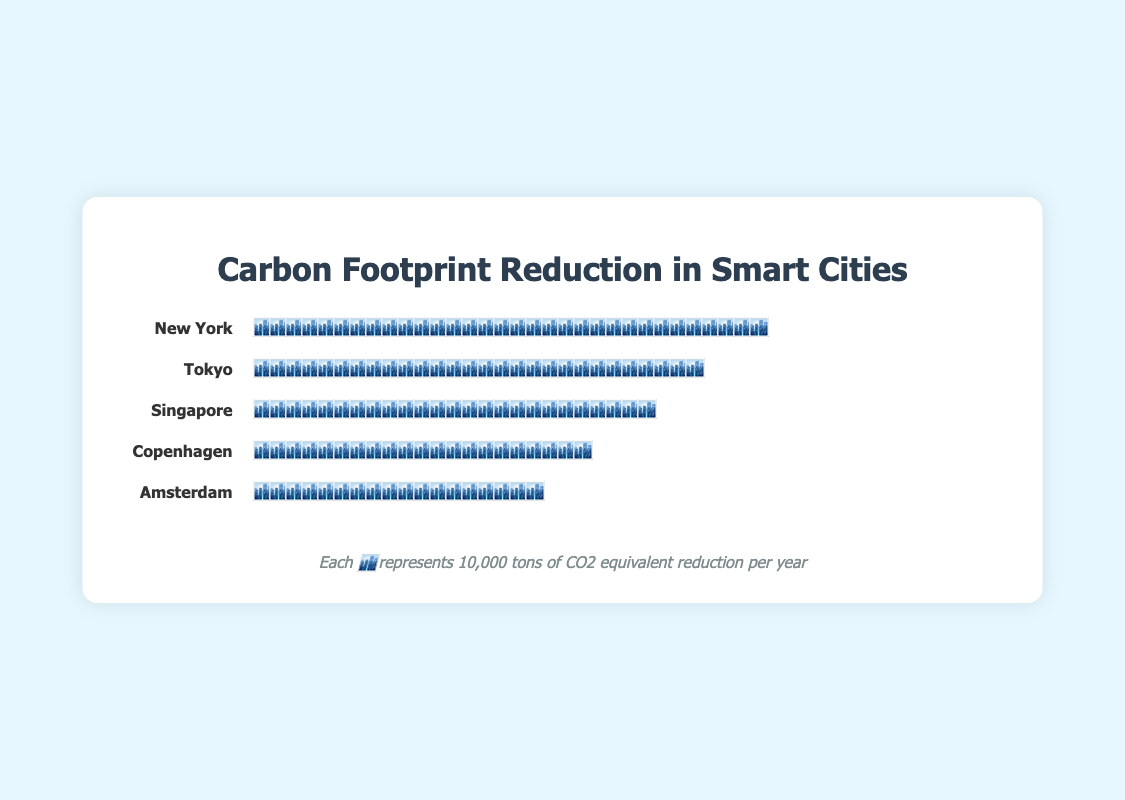What is the total carbon footprint reduction for New York? The figure shows that each 🏙️ icon represents 10,000 tons of CO2 reduction per year. By counting the icons for New York, we see there are 32 icons, so the total reduction is 32 * 10,000.
Answer: 320,000 tons of CO2 Which city has the second highest carbon footprint reduction? The figure indicates that Tokyo has 28 icons representing 280,000 tons of CO2 reduction per year, which is the second highest after New York.
Answer: Tokyo How much more carbon footprint reduction does New York achieve compared to Amsterdam? New York has 32 icons representing 320,000 tons, while Amsterdam has 18 icons representing 180,000 tons. The difference is calculated as 320,000 - 180,000.
Answer: 140,000 tons of CO2 Which city has the lowest carbon footprint reduction? Counting the icons, Amsterdam has the fewest with 18 icons, which represent 180,000 tons of CO2 reduction per year.
Answer: Amsterdam What is the combined carbon footprint reduction of Singapore and Copenhagen? Singapore has 25 icons (250,000 tons) and Copenhagen has 21 icons (210,000 tons). Adding these gives 250,000 + 210,000.
Answer: 460,000 tons of CO2 Which two cities have a combined reduction greater than New York's reduction? New York's reduction is 320,000 tons. Tokyo and Singapore together make 280,000 + 250,000 which sums to 530,000 tons, greater than New York's.
Answer: Tokyo and Singapore How many total icons represent Amsterdam and Copenhagen together? Amsterdam has 18 icons and Copenhagen has 21 icons. Summing them gives 18 + 21.
Answer: 39 icons What's the average carbon footprint reduction per city? The total reduction is the sum of all reductions: 320,000 (New York) + 280,000 (Tokyo) + 250,000 (Singapore) + 210,000 (Copenhagen) + 180,000 (Amsterdam) = 1,240,000 tons. The average is 1,240,000 / 5.
Answer: 248,000 tons of CO2 If each icon represents 10,000 tons of CO2 reduction, how many more icons does Tokyo need to equal New York's reduction? New York has 32 icons and Tokyo has 28. To equal New York, Tokyo needs 32 - 28 icons.
Answer: 4 icons 